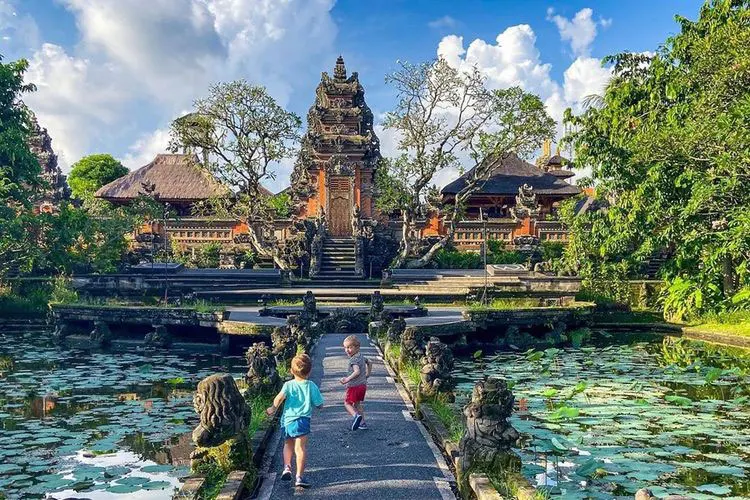What are the key elements in this picture? This image captures the serene beauty of the Ubud Water Palace, a renowned landmark in Bali, Indonesia. The palace, constructed from red brick, stands majestically amidst lush greenery. Its intricate carvings and statues add to its architectural grandeur, reflecting the rich cultural heritage of the region. 

The surrounding gardens are a vibrant display of nature's palette, teeming with diverse plant life. A large pond, dotted with lily pads, enhances the tranquility of the scene. The perspective of the image provides a panoramic view of the palace and its verdant surroundings, inviting the viewer to appreciate the harmony between man-made structures and nature.

In the foreground, two children can be seen walking on a path, adding a touch of life to the tranquil scenery. Their presence brings a sense of scale to the image, highlighting the grandeur of the palace and the expansive gardens. The overall composition of the image offers a glimpse into the peaceful ambiance of the Ubud Water Palace, making it a captivating visual journey for the viewer. 